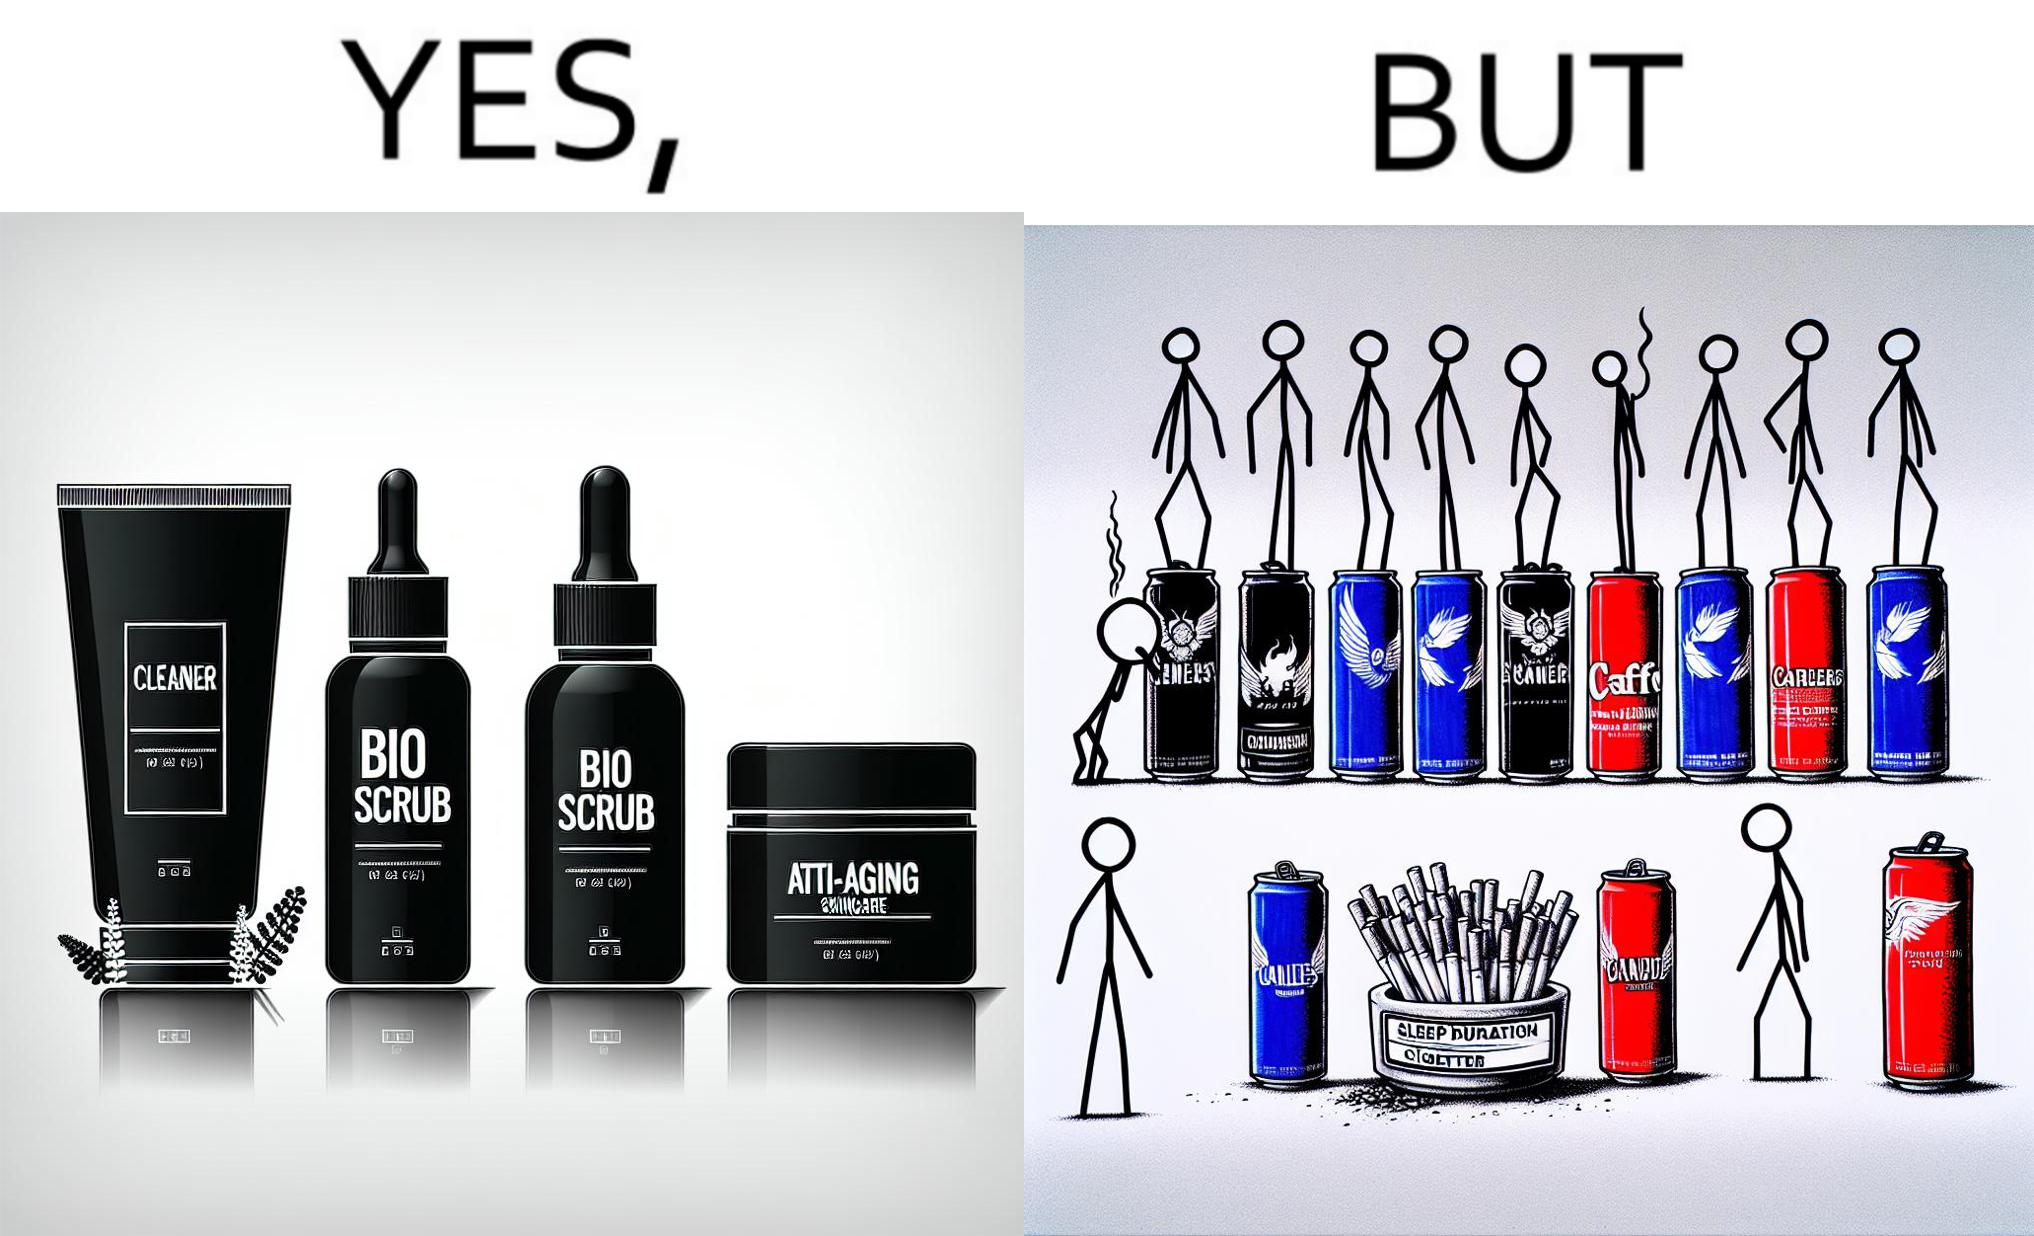Is this a satirical image? Yes, this image is satirical. 